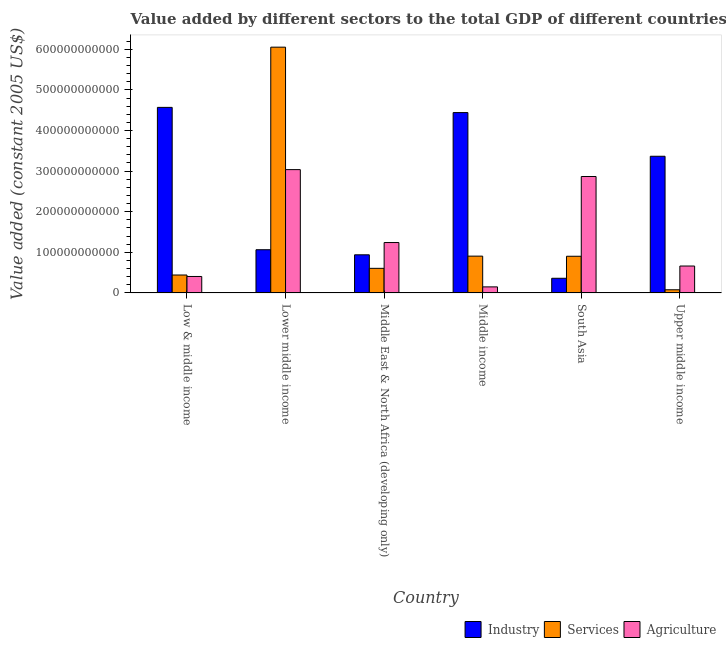How many groups of bars are there?
Offer a very short reply. 6. Are the number of bars on each tick of the X-axis equal?
Your answer should be very brief. Yes. What is the label of the 3rd group of bars from the left?
Provide a succinct answer. Middle East & North Africa (developing only). What is the value added by industrial sector in Middle East & North Africa (developing only)?
Make the answer very short. 9.39e+1. Across all countries, what is the maximum value added by services?
Offer a very short reply. 6.05e+11. Across all countries, what is the minimum value added by services?
Your response must be concise. 7.81e+09. In which country was the value added by industrial sector minimum?
Your answer should be very brief. South Asia. What is the total value added by services in the graph?
Your response must be concise. 8.99e+11. What is the difference between the value added by industrial sector in Middle income and that in South Asia?
Make the answer very short. 4.08e+11. What is the difference between the value added by agricultural sector in Low & middle income and the value added by services in South Asia?
Your response must be concise. -4.98e+1. What is the average value added by agricultural sector per country?
Make the answer very short. 1.39e+11. What is the difference between the value added by services and value added by agricultural sector in Lower middle income?
Your response must be concise. 3.02e+11. In how many countries, is the value added by agricultural sector greater than 380000000000 US$?
Provide a succinct answer. 0. What is the ratio of the value added by services in Middle East & North Africa (developing only) to that in Middle income?
Your response must be concise. 0.67. Is the value added by agricultural sector in Middle income less than that in Upper middle income?
Keep it short and to the point. Yes. Is the difference between the value added by agricultural sector in Middle East & North Africa (developing only) and Middle income greater than the difference between the value added by industrial sector in Middle East & North Africa (developing only) and Middle income?
Keep it short and to the point. Yes. What is the difference between the highest and the second highest value added by industrial sector?
Provide a succinct answer. 1.28e+1. What is the difference between the highest and the lowest value added by industrial sector?
Ensure brevity in your answer.  4.21e+11. What does the 2nd bar from the left in Middle income represents?
Ensure brevity in your answer.  Services. What does the 3rd bar from the right in Middle East & North Africa (developing only) represents?
Offer a very short reply. Industry. What is the difference between two consecutive major ticks on the Y-axis?
Your response must be concise. 1.00e+11. Are the values on the major ticks of Y-axis written in scientific E-notation?
Ensure brevity in your answer.  No. Does the graph contain any zero values?
Provide a short and direct response. No. Does the graph contain grids?
Provide a succinct answer. No. Where does the legend appear in the graph?
Provide a short and direct response. Bottom right. How many legend labels are there?
Ensure brevity in your answer.  3. What is the title of the graph?
Ensure brevity in your answer.  Value added by different sectors to the total GDP of different countries. Does "Labor Tax" appear as one of the legend labels in the graph?
Give a very brief answer. No. What is the label or title of the X-axis?
Your answer should be compact. Country. What is the label or title of the Y-axis?
Ensure brevity in your answer.  Value added (constant 2005 US$). What is the Value added (constant 2005 US$) in Industry in Low & middle income?
Ensure brevity in your answer.  4.57e+11. What is the Value added (constant 2005 US$) in Services in Low & middle income?
Ensure brevity in your answer.  4.42e+1. What is the Value added (constant 2005 US$) in Agriculture in Low & middle income?
Give a very brief answer. 4.05e+1. What is the Value added (constant 2005 US$) of Industry in Lower middle income?
Provide a succinct answer. 1.06e+11. What is the Value added (constant 2005 US$) in Services in Lower middle income?
Your answer should be very brief. 6.05e+11. What is the Value added (constant 2005 US$) of Agriculture in Lower middle income?
Offer a terse response. 3.04e+11. What is the Value added (constant 2005 US$) of Industry in Middle East & North Africa (developing only)?
Offer a very short reply. 9.39e+1. What is the Value added (constant 2005 US$) of Services in Middle East & North Africa (developing only)?
Offer a terse response. 6.06e+1. What is the Value added (constant 2005 US$) of Agriculture in Middle East & North Africa (developing only)?
Offer a very short reply. 1.24e+11. What is the Value added (constant 2005 US$) in Industry in Middle income?
Offer a terse response. 4.44e+11. What is the Value added (constant 2005 US$) in Services in Middle income?
Make the answer very short. 9.06e+1. What is the Value added (constant 2005 US$) of Agriculture in Middle income?
Your response must be concise. 1.49e+1. What is the Value added (constant 2005 US$) of Industry in South Asia?
Your answer should be very brief. 3.61e+1. What is the Value added (constant 2005 US$) in Services in South Asia?
Your response must be concise. 9.04e+1. What is the Value added (constant 2005 US$) of Agriculture in South Asia?
Give a very brief answer. 2.87e+11. What is the Value added (constant 2005 US$) of Industry in Upper middle income?
Make the answer very short. 3.37e+11. What is the Value added (constant 2005 US$) of Services in Upper middle income?
Provide a succinct answer. 7.81e+09. What is the Value added (constant 2005 US$) in Agriculture in Upper middle income?
Give a very brief answer. 6.63e+1. Across all countries, what is the maximum Value added (constant 2005 US$) in Industry?
Your response must be concise. 4.57e+11. Across all countries, what is the maximum Value added (constant 2005 US$) in Services?
Provide a succinct answer. 6.05e+11. Across all countries, what is the maximum Value added (constant 2005 US$) of Agriculture?
Your response must be concise. 3.04e+11. Across all countries, what is the minimum Value added (constant 2005 US$) of Industry?
Keep it short and to the point. 3.61e+1. Across all countries, what is the minimum Value added (constant 2005 US$) in Services?
Your answer should be very brief. 7.81e+09. Across all countries, what is the minimum Value added (constant 2005 US$) in Agriculture?
Give a very brief answer. 1.49e+1. What is the total Value added (constant 2005 US$) in Industry in the graph?
Offer a very short reply. 1.47e+12. What is the total Value added (constant 2005 US$) of Services in the graph?
Your response must be concise. 8.99e+11. What is the total Value added (constant 2005 US$) of Agriculture in the graph?
Make the answer very short. 8.36e+11. What is the difference between the Value added (constant 2005 US$) in Industry in Low & middle income and that in Lower middle income?
Your response must be concise. 3.51e+11. What is the difference between the Value added (constant 2005 US$) in Services in Low & middle income and that in Lower middle income?
Provide a short and direct response. -5.61e+11. What is the difference between the Value added (constant 2005 US$) in Agriculture in Low & middle income and that in Lower middle income?
Offer a terse response. -2.63e+11. What is the difference between the Value added (constant 2005 US$) in Industry in Low & middle income and that in Middle East & North Africa (developing only)?
Provide a short and direct response. 3.63e+11. What is the difference between the Value added (constant 2005 US$) of Services in Low & middle income and that in Middle East & North Africa (developing only)?
Give a very brief answer. -1.64e+1. What is the difference between the Value added (constant 2005 US$) of Agriculture in Low & middle income and that in Middle East & North Africa (developing only)?
Provide a short and direct response. -8.36e+1. What is the difference between the Value added (constant 2005 US$) in Industry in Low & middle income and that in Middle income?
Make the answer very short. 1.28e+1. What is the difference between the Value added (constant 2005 US$) of Services in Low & middle income and that in Middle income?
Provide a succinct answer. -4.65e+1. What is the difference between the Value added (constant 2005 US$) in Agriculture in Low & middle income and that in Middle income?
Make the answer very short. 2.56e+1. What is the difference between the Value added (constant 2005 US$) of Industry in Low & middle income and that in South Asia?
Provide a succinct answer. 4.21e+11. What is the difference between the Value added (constant 2005 US$) in Services in Low & middle income and that in South Asia?
Make the answer very short. -4.62e+1. What is the difference between the Value added (constant 2005 US$) in Agriculture in Low & middle income and that in South Asia?
Ensure brevity in your answer.  -2.46e+11. What is the difference between the Value added (constant 2005 US$) in Industry in Low & middle income and that in Upper middle income?
Offer a terse response. 1.20e+11. What is the difference between the Value added (constant 2005 US$) in Services in Low & middle income and that in Upper middle income?
Provide a short and direct response. 3.64e+1. What is the difference between the Value added (constant 2005 US$) in Agriculture in Low & middle income and that in Upper middle income?
Provide a short and direct response. -2.58e+1. What is the difference between the Value added (constant 2005 US$) of Industry in Lower middle income and that in Middle East & North Africa (developing only)?
Your answer should be compact. 1.25e+1. What is the difference between the Value added (constant 2005 US$) of Services in Lower middle income and that in Middle East & North Africa (developing only)?
Provide a short and direct response. 5.45e+11. What is the difference between the Value added (constant 2005 US$) of Agriculture in Lower middle income and that in Middle East & North Africa (developing only)?
Your answer should be very brief. 1.80e+11. What is the difference between the Value added (constant 2005 US$) of Industry in Lower middle income and that in Middle income?
Offer a terse response. -3.38e+11. What is the difference between the Value added (constant 2005 US$) in Services in Lower middle income and that in Middle income?
Your answer should be very brief. 5.15e+11. What is the difference between the Value added (constant 2005 US$) in Agriculture in Lower middle income and that in Middle income?
Keep it short and to the point. 2.89e+11. What is the difference between the Value added (constant 2005 US$) in Industry in Lower middle income and that in South Asia?
Provide a short and direct response. 7.03e+1. What is the difference between the Value added (constant 2005 US$) in Services in Lower middle income and that in South Asia?
Keep it short and to the point. 5.15e+11. What is the difference between the Value added (constant 2005 US$) of Agriculture in Lower middle income and that in South Asia?
Offer a very short reply. 1.69e+1. What is the difference between the Value added (constant 2005 US$) in Industry in Lower middle income and that in Upper middle income?
Your response must be concise. -2.30e+11. What is the difference between the Value added (constant 2005 US$) of Services in Lower middle income and that in Upper middle income?
Your answer should be very brief. 5.97e+11. What is the difference between the Value added (constant 2005 US$) in Agriculture in Lower middle income and that in Upper middle income?
Provide a succinct answer. 2.37e+11. What is the difference between the Value added (constant 2005 US$) of Industry in Middle East & North Africa (developing only) and that in Middle income?
Offer a very short reply. -3.50e+11. What is the difference between the Value added (constant 2005 US$) in Services in Middle East & North Africa (developing only) and that in Middle income?
Offer a terse response. -3.00e+1. What is the difference between the Value added (constant 2005 US$) of Agriculture in Middle East & North Africa (developing only) and that in Middle income?
Provide a succinct answer. 1.09e+11. What is the difference between the Value added (constant 2005 US$) in Industry in Middle East & North Africa (developing only) and that in South Asia?
Provide a short and direct response. 5.78e+1. What is the difference between the Value added (constant 2005 US$) of Services in Middle East & North Africa (developing only) and that in South Asia?
Your response must be concise. -2.98e+1. What is the difference between the Value added (constant 2005 US$) of Agriculture in Middle East & North Africa (developing only) and that in South Asia?
Keep it short and to the point. -1.63e+11. What is the difference between the Value added (constant 2005 US$) of Industry in Middle East & North Africa (developing only) and that in Upper middle income?
Provide a short and direct response. -2.43e+11. What is the difference between the Value added (constant 2005 US$) of Services in Middle East & North Africa (developing only) and that in Upper middle income?
Give a very brief answer. 5.28e+1. What is the difference between the Value added (constant 2005 US$) in Agriculture in Middle East & North Africa (developing only) and that in Upper middle income?
Keep it short and to the point. 5.78e+1. What is the difference between the Value added (constant 2005 US$) in Industry in Middle income and that in South Asia?
Give a very brief answer. 4.08e+11. What is the difference between the Value added (constant 2005 US$) of Services in Middle income and that in South Asia?
Make the answer very short. 2.74e+08. What is the difference between the Value added (constant 2005 US$) in Agriculture in Middle income and that in South Asia?
Your answer should be compact. -2.72e+11. What is the difference between the Value added (constant 2005 US$) in Industry in Middle income and that in Upper middle income?
Offer a terse response. 1.08e+11. What is the difference between the Value added (constant 2005 US$) of Services in Middle income and that in Upper middle income?
Give a very brief answer. 8.28e+1. What is the difference between the Value added (constant 2005 US$) of Agriculture in Middle income and that in Upper middle income?
Provide a succinct answer. -5.14e+1. What is the difference between the Value added (constant 2005 US$) of Industry in South Asia and that in Upper middle income?
Make the answer very short. -3.01e+11. What is the difference between the Value added (constant 2005 US$) in Services in South Asia and that in Upper middle income?
Offer a very short reply. 8.25e+1. What is the difference between the Value added (constant 2005 US$) in Agriculture in South Asia and that in Upper middle income?
Your answer should be very brief. 2.20e+11. What is the difference between the Value added (constant 2005 US$) of Industry in Low & middle income and the Value added (constant 2005 US$) of Services in Lower middle income?
Give a very brief answer. -1.48e+11. What is the difference between the Value added (constant 2005 US$) in Industry in Low & middle income and the Value added (constant 2005 US$) in Agriculture in Lower middle income?
Provide a succinct answer. 1.53e+11. What is the difference between the Value added (constant 2005 US$) of Services in Low & middle income and the Value added (constant 2005 US$) of Agriculture in Lower middle income?
Offer a very short reply. -2.60e+11. What is the difference between the Value added (constant 2005 US$) of Industry in Low & middle income and the Value added (constant 2005 US$) of Services in Middle East & North Africa (developing only)?
Give a very brief answer. 3.96e+11. What is the difference between the Value added (constant 2005 US$) in Industry in Low & middle income and the Value added (constant 2005 US$) in Agriculture in Middle East & North Africa (developing only)?
Your answer should be compact. 3.33e+11. What is the difference between the Value added (constant 2005 US$) in Services in Low & middle income and the Value added (constant 2005 US$) in Agriculture in Middle East & North Africa (developing only)?
Your response must be concise. -7.99e+1. What is the difference between the Value added (constant 2005 US$) of Industry in Low & middle income and the Value added (constant 2005 US$) of Services in Middle income?
Provide a short and direct response. 3.66e+11. What is the difference between the Value added (constant 2005 US$) in Industry in Low & middle income and the Value added (constant 2005 US$) in Agriculture in Middle income?
Your response must be concise. 4.42e+11. What is the difference between the Value added (constant 2005 US$) of Services in Low & middle income and the Value added (constant 2005 US$) of Agriculture in Middle income?
Give a very brief answer. 2.93e+1. What is the difference between the Value added (constant 2005 US$) in Industry in Low & middle income and the Value added (constant 2005 US$) in Services in South Asia?
Your response must be concise. 3.67e+11. What is the difference between the Value added (constant 2005 US$) in Industry in Low & middle income and the Value added (constant 2005 US$) in Agriculture in South Asia?
Give a very brief answer. 1.70e+11. What is the difference between the Value added (constant 2005 US$) of Services in Low & middle income and the Value added (constant 2005 US$) of Agriculture in South Asia?
Your answer should be very brief. -2.43e+11. What is the difference between the Value added (constant 2005 US$) in Industry in Low & middle income and the Value added (constant 2005 US$) in Services in Upper middle income?
Offer a very short reply. 4.49e+11. What is the difference between the Value added (constant 2005 US$) of Industry in Low & middle income and the Value added (constant 2005 US$) of Agriculture in Upper middle income?
Keep it short and to the point. 3.91e+11. What is the difference between the Value added (constant 2005 US$) of Services in Low & middle income and the Value added (constant 2005 US$) of Agriculture in Upper middle income?
Provide a short and direct response. -2.21e+1. What is the difference between the Value added (constant 2005 US$) of Industry in Lower middle income and the Value added (constant 2005 US$) of Services in Middle East & North Africa (developing only)?
Provide a succinct answer. 4.58e+1. What is the difference between the Value added (constant 2005 US$) of Industry in Lower middle income and the Value added (constant 2005 US$) of Agriculture in Middle East & North Africa (developing only)?
Your response must be concise. -1.77e+1. What is the difference between the Value added (constant 2005 US$) in Services in Lower middle income and the Value added (constant 2005 US$) in Agriculture in Middle East & North Africa (developing only)?
Provide a succinct answer. 4.81e+11. What is the difference between the Value added (constant 2005 US$) in Industry in Lower middle income and the Value added (constant 2005 US$) in Services in Middle income?
Make the answer very short. 1.58e+1. What is the difference between the Value added (constant 2005 US$) of Industry in Lower middle income and the Value added (constant 2005 US$) of Agriculture in Middle income?
Give a very brief answer. 9.15e+1. What is the difference between the Value added (constant 2005 US$) in Services in Lower middle income and the Value added (constant 2005 US$) in Agriculture in Middle income?
Offer a terse response. 5.90e+11. What is the difference between the Value added (constant 2005 US$) of Industry in Lower middle income and the Value added (constant 2005 US$) of Services in South Asia?
Ensure brevity in your answer.  1.61e+1. What is the difference between the Value added (constant 2005 US$) in Industry in Lower middle income and the Value added (constant 2005 US$) in Agriculture in South Asia?
Your answer should be compact. -1.80e+11. What is the difference between the Value added (constant 2005 US$) of Services in Lower middle income and the Value added (constant 2005 US$) of Agriculture in South Asia?
Your answer should be very brief. 3.19e+11. What is the difference between the Value added (constant 2005 US$) in Industry in Lower middle income and the Value added (constant 2005 US$) in Services in Upper middle income?
Make the answer very short. 9.86e+1. What is the difference between the Value added (constant 2005 US$) of Industry in Lower middle income and the Value added (constant 2005 US$) of Agriculture in Upper middle income?
Ensure brevity in your answer.  4.01e+1. What is the difference between the Value added (constant 2005 US$) in Services in Lower middle income and the Value added (constant 2005 US$) in Agriculture in Upper middle income?
Make the answer very short. 5.39e+11. What is the difference between the Value added (constant 2005 US$) of Industry in Middle East & North Africa (developing only) and the Value added (constant 2005 US$) of Services in Middle income?
Keep it short and to the point. 3.28e+09. What is the difference between the Value added (constant 2005 US$) in Industry in Middle East & North Africa (developing only) and the Value added (constant 2005 US$) in Agriculture in Middle income?
Your answer should be compact. 7.90e+1. What is the difference between the Value added (constant 2005 US$) of Services in Middle East & North Africa (developing only) and the Value added (constant 2005 US$) of Agriculture in Middle income?
Offer a terse response. 4.57e+1. What is the difference between the Value added (constant 2005 US$) in Industry in Middle East & North Africa (developing only) and the Value added (constant 2005 US$) in Services in South Asia?
Provide a short and direct response. 3.55e+09. What is the difference between the Value added (constant 2005 US$) in Industry in Middle East & North Africa (developing only) and the Value added (constant 2005 US$) in Agriculture in South Asia?
Provide a succinct answer. -1.93e+11. What is the difference between the Value added (constant 2005 US$) of Services in Middle East & North Africa (developing only) and the Value added (constant 2005 US$) of Agriculture in South Asia?
Your response must be concise. -2.26e+11. What is the difference between the Value added (constant 2005 US$) of Industry in Middle East & North Africa (developing only) and the Value added (constant 2005 US$) of Services in Upper middle income?
Your answer should be compact. 8.61e+1. What is the difference between the Value added (constant 2005 US$) of Industry in Middle East & North Africa (developing only) and the Value added (constant 2005 US$) of Agriculture in Upper middle income?
Ensure brevity in your answer.  2.76e+1. What is the difference between the Value added (constant 2005 US$) of Services in Middle East & North Africa (developing only) and the Value added (constant 2005 US$) of Agriculture in Upper middle income?
Keep it short and to the point. -5.70e+09. What is the difference between the Value added (constant 2005 US$) of Industry in Middle income and the Value added (constant 2005 US$) of Services in South Asia?
Keep it short and to the point. 3.54e+11. What is the difference between the Value added (constant 2005 US$) of Industry in Middle income and the Value added (constant 2005 US$) of Agriculture in South Asia?
Provide a succinct answer. 1.57e+11. What is the difference between the Value added (constant 2005 US$) in Services in Middle income and the Value added (constant 2005 US$) in Agriculture in South Asia?
Give a very brief answer. -1.96e+11. What is the difference between the Value added (constant 2005 US$) of Industry in Middle income and the Value added (constant 2005 US$) of Services in Upper middle income?
Ensure brevity in your answer.  4.36e+11. What is the difference between the Value added (constant 2005 US$) of Industry in Middle income and the Value added (constant 2005 US$) of Agriculture in Upper middle income?
Your response must be concise. 3.78e+11. What is the difference between the Value added (constant 2005 US$) in Services in Middle income and the Value added (constant 2005 US$) in Agriculture in Upper middle income?
Give a very brief answer. 2.43e+1. What is the difference between the Value added (constant 2005 US$) in Industry in South Asia and the Value added (constant 2005 US$) in Services in Upper middle income?
Provide a short and direct response. 2.83e+1. What is the difference between the Value added (constant 2005 US$) of Industry in South Asia and the Value added (constant 2005 US$) of Agriculture in Upper middle income?
Provide a succinct answer. -3.02e+1. What is the difference between the Value added (constant 2005 US$) in Services in South Asia and the Value added (constant 2005 US$) in Agriculture in Upper middle income?
Make the answer very short. 2.41e+1. What is the average Value added (constant 2005 US$) in Industry per country?
Your response must be concise. 2.46e+11. What is the average Value added (constant 2005 US$) of Services per country?
Offer a terse response. 1.50e+11. What is the average Value added (constant 2005 US$) of Agriculture per country?
Offer a very short reply. 1.39e+11. What is the difference between the Value added (constant 2005 US$) in Industry and Value added (constant 2005 US$) in Services in Low & middle income?
Provide a succinct answer. 4.13e+11. What is the difference between the Value added (constant 2005 US$) in Industry and Value added (constant 2005 US$) in Agriculture in Low & middle income?
Offer a terse response. 4.16e+11. What is the difference between the Value added (constant 2005 US$) in Services and Value added (constant 2005 US$) in Agriculture in Low & middle income?
Your response must be concise. 3.64e+09. What is the difference between the Value added (constant 2005 US$) of Industry and Value added (constant 2005 US$) of Services in Lower middle income?
Offer a terse response. -4.99e+11. What is the difference between the Value added (constant 2005 US$) in Industry and Value added (constant 2005 US$) in Agriculture in Lower middle income?
Keep it short and to the point. -1.97e+11. What is the difference between the Value added (constant 2005 US$) of Services and Value added (constant 2005 US$) of Agriculture in Lower middle income?
Your response must be concise. 3.02e+11. What is the difference between the Value added (constant 2005 US$) of Industry and Value added (constant 2005 US$) of Services in Middle East & North Africa (developing only)?
Your answer should be very brief. 3.33e+1. What is the difference between the Value added (constant 2005 US$) of Industry and Value added (constant 2005 US$) of Agriculture in Middle East & North Africa (developing only)?
Ensure brevity in your answer.  -3.02e+1. What is the difference between the Value added (constant 2005 US$) of Services and Value added (constant 2005 US$) of Agriculture in Middle East & North Africa (developing only)?
Make the answer very short. -6.35e+1. What is the difference between the Value added (constant 2005 US$) of Industry and Value added (constant 2005 US$) of Services in Middle income?
Provide a succinct answer. 3.54e+11. What is the difference between the Value added (constant 2005 US$) in Industry and Value added (constant 2005 US$) in Agriculture in Middle income?
Offer a very short reply. 4.29e+11. What is the difference between the Value added (constant 2005 US$) of Services and Value added (constant 2005 US$) of Agriculture in Middle income?
Give a very brief answer. 7.57e+1. What is the difference between the Value added (constant 2005 US$) in Industry and Value added (constant 2005 US$) in Services in South Asia?
Offer a terse response. -5.42e+1. What is the difference between the Value added (constant 2005 US$) in Industry and Value added (constant 2005 US$) in Agriculture in South Asia?
Offer a very short reply. -2.51e+11. What is the difference between the Value added (constant 2005 US$) in Services and Value added (constant 2005 US$) in Agriculture in South Asia?
Ensure brevity in your answer.  -1.96e+11. What is the difference between the Value added (constant 2005 US$) in Industry and Value added (constant 2005 US$) in Services in Upper middle income?
Offer a very short reply. 3.29e+11. What is the difference between the Value added (constant 2005 US$) of Industry and Value added (constant 2005 US$) of Agriculture in Upper middle income?
Offer a very short reply. 2.70e+11. What is the difference between the Value added (constant 2005 US$) in Services and Value added (constant 2005 US$) in Agriculture in Upper middle income?
Your answer should be very brief. -5.85e+1. What is the ratio of the Value added (constant 2005 US$) in Industry in Low & middle income to that in Lower middle income?
Give a very brief answer. 4.29. What is the ratio of the Value added (constant 2005 US$) in Services in Low & middle income to that in Lower middle income?
Your answer should be very brief. 0.07. What is the ratio of the Value added (constant 2005 US$) in Agriculture in Low & middle income to that in Lower middle income?
Your response must be concise. 0.13. What is the ratio of the Value added (constant 2005 US$) of Industry in Low & middle income to that in Middle East & North Africa (developing only)?
Make the answer very short. 4.87. What is the ratio of the Value added (constant 2005 US$) in Services in Low & middle income to that in Middle East & North Africa (developing only)?
Offer a terse response. 0.73. What is the ratio of the Value added (constant 2005 US$) of Agriculture in Low & middle income to that in Middle East & North Africa (developing only)?
Offer a very short reply. 0.33. What is the ratio of the Value added (constant 2005 US$) in Industry in Low & middle income to that in Middle income?
Your response must be concise. 1.03. What is the ratio of the Value added (constant 2005 US$) of Services in Low & middle income to that in Middle income?
Your answer should be compact. 0.49. What is the ratio of the Value added (constant 2005 US$) of Agriculture in Low & middle income to that in Middle income?
Your answer should be compact. 2.72. What is the ratio of the Value added (constant 2005 US$) in Industry in Low & middle income to that in South Asia?
Make the answer very short. 12.65. What is the ratio of the Value added (constant 2005 US$) of Services in Low & middle income to that in South Asia?
Provide a short and direct response. 0.49. What is the ratio of the Value added (constant 2005 US$) of Agriculture in Low & middle income to that in South Asia?
Give a very brief answer. 0.14. What is the ratio of the Value added (constant 2005 US$) in Industry in Low & middle income to that in Upper middle income?
Offer a very short reply. 1.36. What is the ratio of the Value added (constant 2005 US$) of Services in Low & middle income to that in Upper middle income?
Your response must be concise. 5.66. What is the ratio of the Value added (constant 2005 US$) of Agriculture in Low & middle income to that in Upper middle income?
Offer a terse response. 0.61. What is the ratio of the Value added (constant 2005 US$) of Industry in Lower middle income to that in Middle East & North Africa (developing only)?
Your response must be concise. 1.13. What is the ratio of the Value added (constant 2005 US$) in Services in Lower middle income to that in Middle East & North Africa (developing only)?
Offer a terse response. 9.99. What is the ratio of the Value added (constant 2005 US$) in Agriculture in Lower middle income to that in Middle East & North Africa (developing only)?
Ensure brevity in your answer.  2.45. What is the ratio of the Value added (constant 2005 US$) of Industry in Lower middle income to that in Middle income?
Ensure brevity in your answer.  0.24. What is the ratio of the Value added (constant 2005 US$) in Services in Lower middle income to that in Middle income?
Ensure brevity in your answer.  6.68. What is the ratio of the Value added (constant 2005 US$) of Agriculture in Lower middle income to that in Middle income?
Ensure brevity in your answer.  20.38. What is the ratio of the Value added (constant 2005 US$) of Industry in Lower middle income to that in South Asia?
Give a very brief answer. 2.95. What is the ratio of the Value added (constant 2005 US$) in Services in Lower middle income to that in South Asia?
Your answer should be very brief. 6.7. What is the ratio of the Value added (constant 2005 US$) of Agriculture in Lower middle income to that in South Asia?
Ensure brevity in your answer.  1.06. What is the ratio of the Value added (constant 2005 US$) of Industry in Lower middle income to that in Upper middle income?
Give a very brief answer. 0.32. What is the ratio of the Value added (constant 2005 US$) of Services in Lower middle income to that in Upper middle income?
Give a very brief answer. 77.53. What is the ratio of the Value added (constant 2005 US$) of Agriculture in Lower middle income to that in Upper middle income?
Your response must be concise. 4.58. What is the ratio of the Value added (constant 2005 US$) in Industry in Middle East & North Africa (developing only) to that in Middle income?
Offer a very short reply. 0.21. What is the ratio of the Value added (constant 2005 US$) in Services in Middle East & North Africa (developing only) to that in Middle income?
Provide a succinct answer. 0.67. What is the ratio of the Value added (constant 2005 US$) in Agriculture in Middle East & North Africa (developing only) to that in Middle income?
Give a very brief answer. 8.33. What is the ratio of the Value added (constant 2005 US$) of Industry in Middle East & North Africa (developing only) to that in South Asia?
Ensure brevity in your answer.  2.6. What is the ratio of the Value added (constant 2005 US$) in Services in Middle East & North Africa (developing only) to that in South Asia?
Offer a very short reply. 0.67. What is the ratio of the Value added (constant 2005 US$) in Agriculture in Middle East & North Africa (developing only) to that in South Asia?
Ensure brevity in your answer.  0.43. What is the ratio of the Value added (constant 2005 US$) in Industry in Middle East & North Africa (developing only) to that in Upper middle income?
Provide a succinct answer. 0.28. What is the ratio of the Value added (constant 2005 US$) of Services in Middle East & North Africa (developing only) to that in Upper middle income?
Provide a succinct answer. 7.76. What is the ratio of the Value added (constant 2005 US$) in Agriculture in Middle East & North Africa (developing only) to that in Upper middle income?
Your answer should be very brief. 1.87. What is the ratio of the Value added (constant 2005 US$) of Industry in Middle income to that in South Asia?
Make the answer very short. 12.3. What is the ratio of the Value added (constant 2005 US$) of Services in Middle income to that in South Asia?
Offer a terse response. 1. What is the ratio of the Value added (constant 2005 US$) of Agriculture in Middle income to that in South Asia?
Your answer should be very brief. 0.05. What is the ratio of the Value added (constant 2005 US$) in Industry in Middle income to that in Upper middle income?
Offer a very short reply. 1.32. What is the ratio of the Value added (constant 2005 US$) in Services in Middle income to that in Upper middle income?
Ensure brevity in your answer.  11.61. What is the ratio of the Value added (constant 2005 US$) in Agriculture in Middle income to that in Upper middle income?
Give a very brief answer. 0.22. What is the ratio of the Value added (constant 2005 US$) of Industry in South Asia to that in Upper middle income?
Provide a short and direct response. 0.11. What is the ratio of the Value added (constant 2005 US$) in Services in South Asia to that in Upper middle income?
Give a very brief answer. 11.57. What is the ratio of the Value added (constant 2005 US$) in Agriculture in South Asia to that in Upper middle income?
Keep it short and to the point. 4.33. What is the difference between the highest and the second highest Value added (constant 2005 US$) of Industry?
Provide a succinct answer. 1.28e+1. What is the difference between the highest and the second highest Value added (constant 2005 US$) of Services?
Your response must be concise. 5.15e+11. What is the difference between the highest and the second highest Value added (constant 2005 US$) of Agriculture?
Your answer should be compact. 1.69e+1. What is the difference between the highest and the lowest Value added (constant 2005 US$) in Industry?
Provide a short and direct response. 4.21e+11. What is the difference between the highest and the lowest Value added (constant 2005 US$) of Services?
Your response must be concise. 5.97e+11. What is the difference between the highest and the lowest Value added (constant 2005 US$) of Agriculture?
Ensure brevity in your answer.  2.89e+11. 